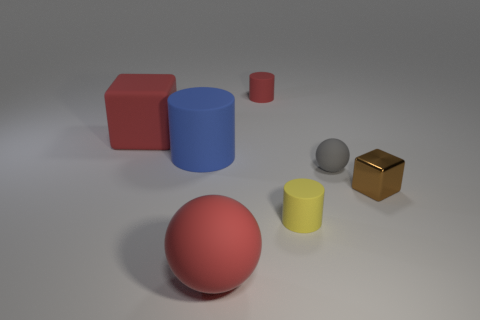Add 1 small brown rubber cylinders. How many objects exist? 8 Subtract all yellow matte cylinders. How many cylinders are left? 2 Subtract all blue cylinders. How many cylinders are left? 2 Subtract 2 cylinders. How many cylinders are left? 1 Add 1 tiny rubber spheres. How many tiny rubber spheres exist? 2 Subtract 1 brown blocks. How many objects are left? 6 Subtract all cubes. How many objects are left? 5 Subtract all yellow spheres. Subtract all yellow cylinders. How many spheres are left? 2 Subtract all big yellow cubes. Subtract all big rubber cylinders. How many objects are left? 6 Add 3 big red matte blocks. How many big red matte blocks are left? 4 